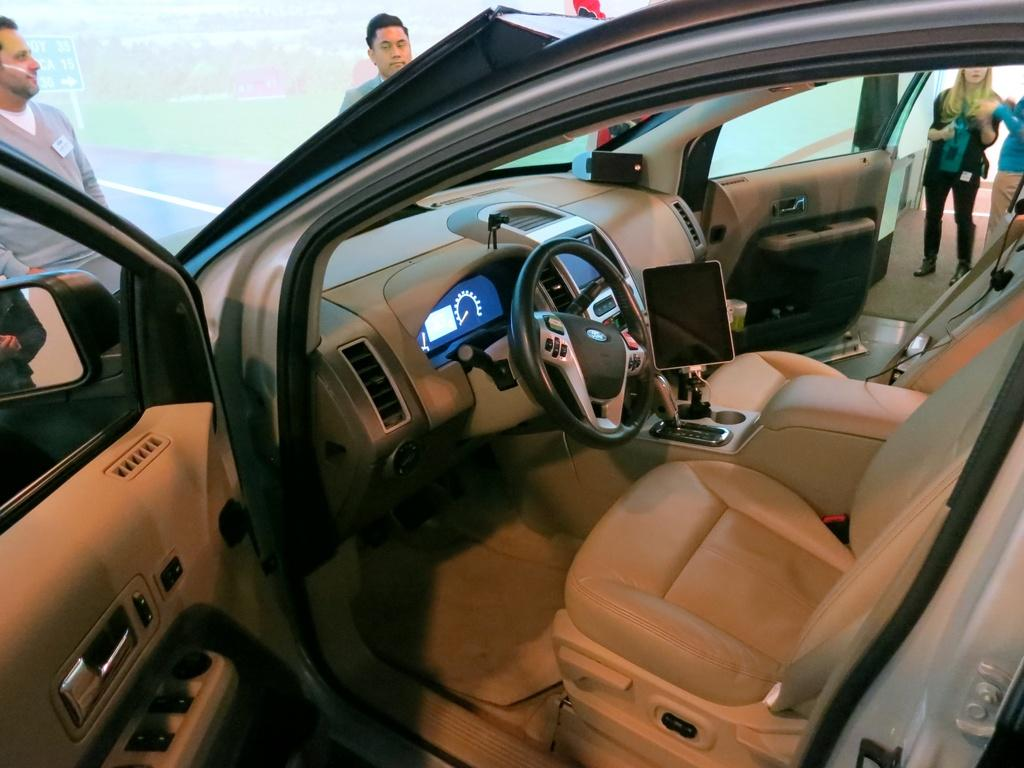What is the main subject of the picture? The main subject of the picture is a car. What features does the car have? The car has seats, a steering wheel, and doors. What can be seen in the background of the picture? There are people standing in the background of the picture, as well as other objects. What type of advertisement can be seen on the car in the image? There is no advertisement visible on the car in the image. How many bikes are parked next to the car in the image? There are no bikes present in the image; it only features a car and people in the background. 